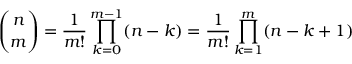<formula> <loc_0><loc_0><loc_500><loc_500>{ \binom { n } { m } } = { \frac { 1 } { m ! } } \prod _ { k = 0 } ^ { m - 1 } ( n - k ) = { \frac { 1 } { m ! } } \prod _ { k = 1 } ^ { m } ( n - k + 1 )</formula> 